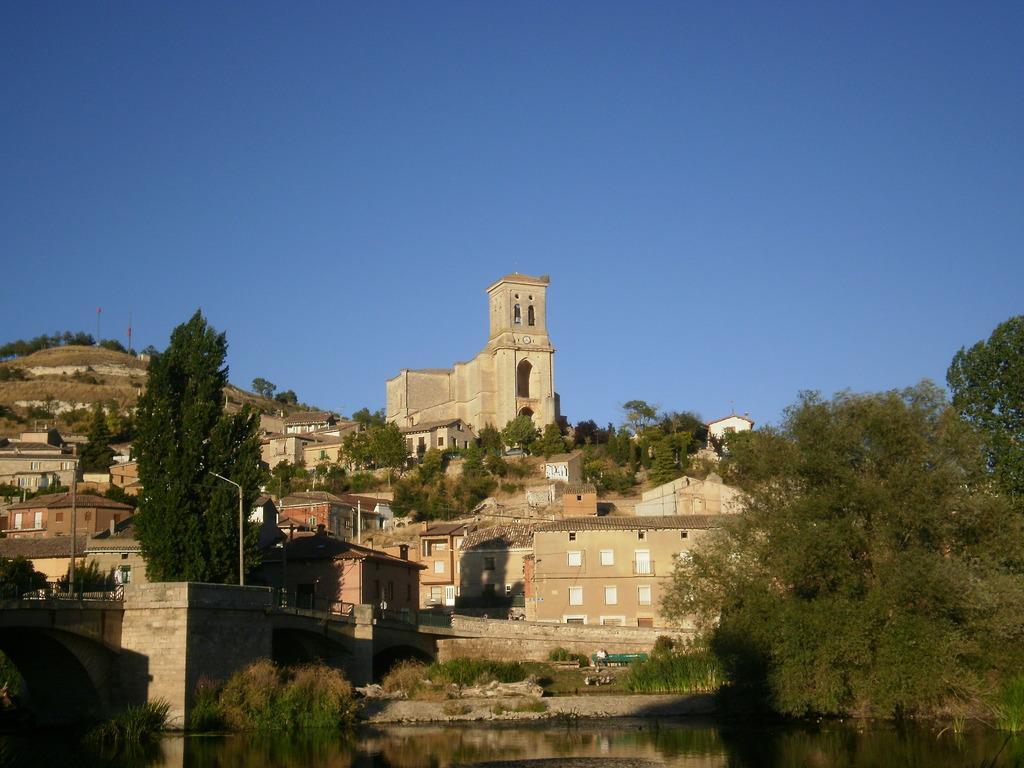Please provide a concise description of this image. In this image, I can see the buildings and trees on a hill. At the bottom of the image, I can see water. In the background, there is the sky. 